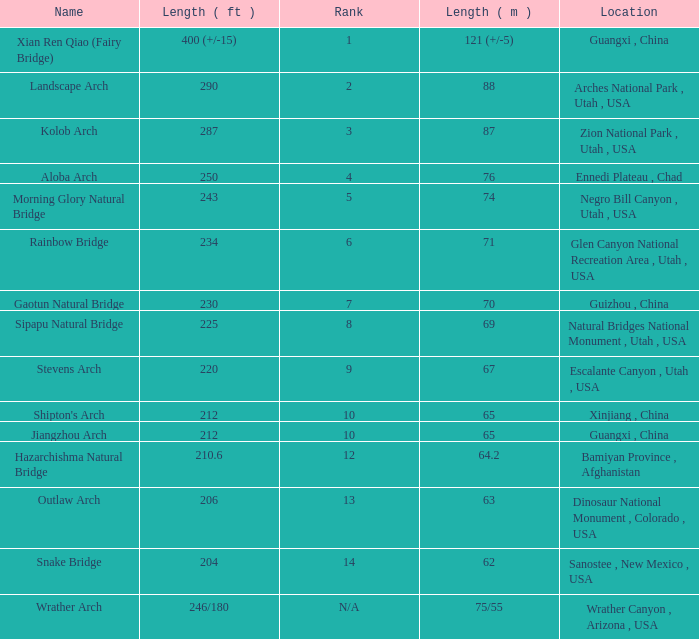What is the length in feet of the Jiangzhou arch? 212.0. 